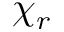Convert formula to latex. <formula><loc_0><loc_0><loc_500><loc_500>\chi _ { r }</formula> 